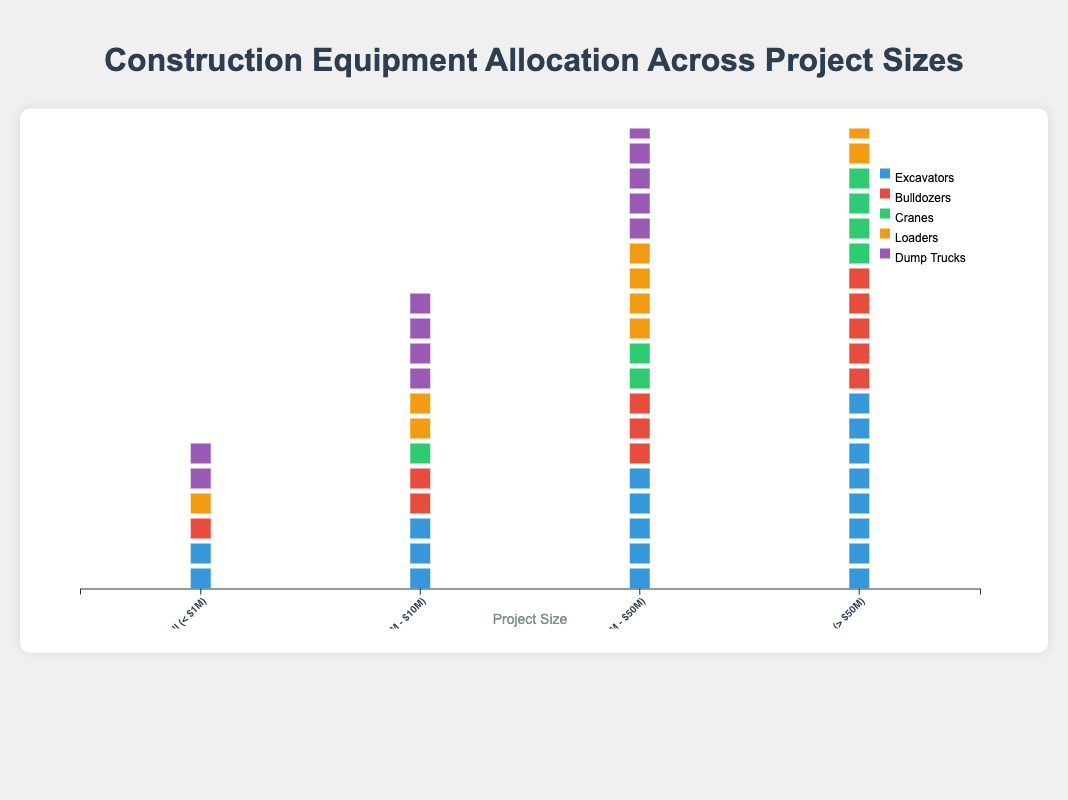what is the title of the plot? The title is typically located at the top center of the plot in a larger, bold font. By reading it, you can identify it as "Construction Equipment Allocation Across Project Sizes".
Answer: Construction Equipment Allocation Across Project Sizes Which project size utilizes the most dump trucks? Observing the column heights for Dump Trucks across all project sizes, the tallest column belongs to the "Mega (> $50M)" size, indicating it uses the most Dump Trucks.
Answer: Mega (> $50M) How many loaders are allocated to medium-sized projects? By looking at the number of icons representing Loaders in the "Medium ($1M - $10M)" size column, you can count that there are 2 icons.
Answer: 2 What is the least used equipment type for small projects? In the "Small (< $1M)" size column, you can see the counts of equipment. Cranes have a count of 0, which is the least among all types.
Answer: Cranes Compare the number of excavators used in Mega and Small projects. Look at the Excavators count in both columns: "Mega (> $50M)" has 8 and "Small (< $1M)" has 2. Comparing these, Mega projects use significantly more.
Answer: Mega projects use 6 more Excavators than Small projects How does the use of cranes change from large to mega projects? Check the count of Cranes in the "Large ($10M - $50M)" and "Mega (> $50M)" columns. Large projects have 2 while Mega projects have 4. The use doubles from large to mega projects.
Answer: The use of cranes doubles Which equipment type generally increases its count as project size increases? Observe the trend lines of each equipment type across different project sizes. All equipment types incrementally increase as the project size grows from 'Small' to 'Mega'.
Answer: All equipment types How many total equipment units are used in medium-sized projects? Add the counts of all equipment types in medium projects: 3 (Excavators) + 2 (Bulldozers) + 1 (Cranes) + 2 (Loaders) + 4 (Dump Trucks) = 12 units.
Answer: 12 units Is the allocation of dump trucks and loaders balanced across all project sizes? By visually comparing the columns of Dump Trucks and Loaders across all sizes, you can see each type increases steadily with project size. However, Dump Trucks are more heavily allocated overall.
Answer: No, more Dump Trucks are allocated compared to Loaders 